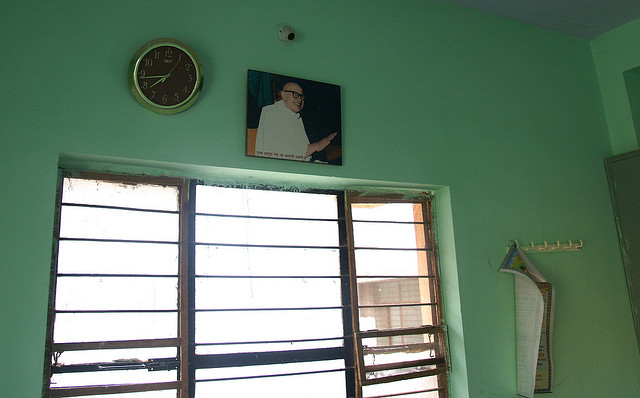Identify the text displayed in this image. 12 11 10 9 8 7 6 1 2 3 4 5 